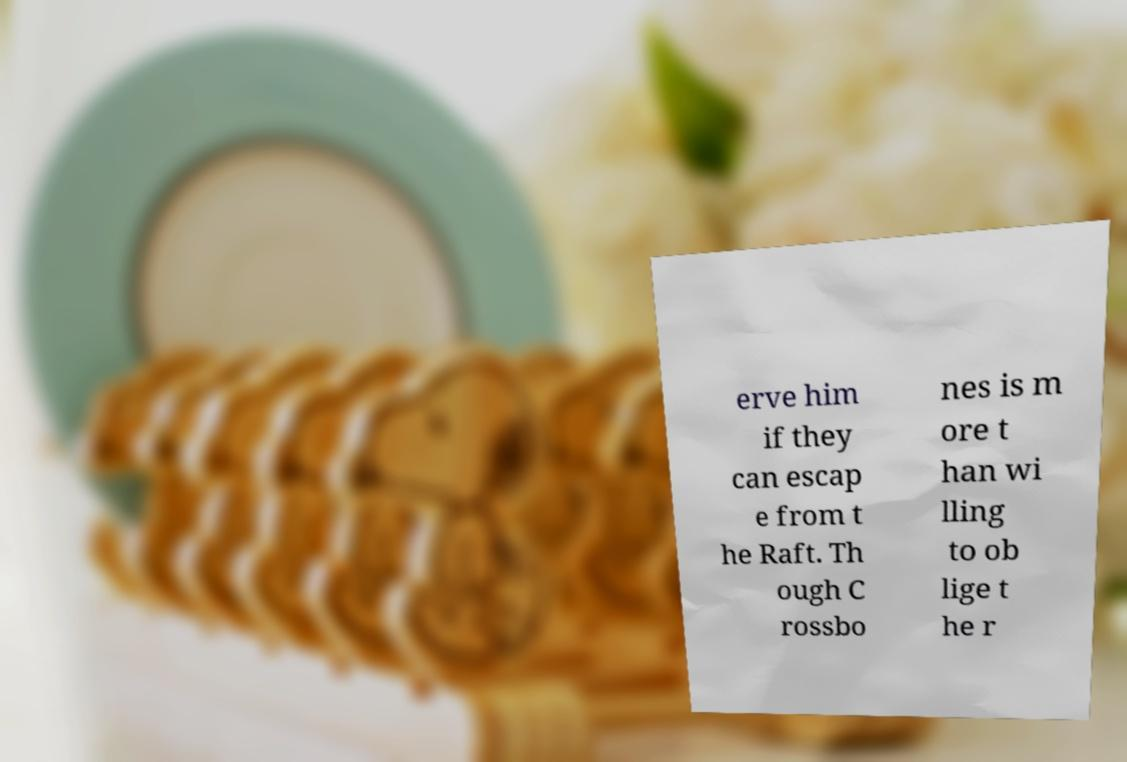Please identify and transcribe the text found in this image. erve him if they can escap e from t he Raft. Th ough C rossbo nes is m ore t han wi lling to ob lige t he r 